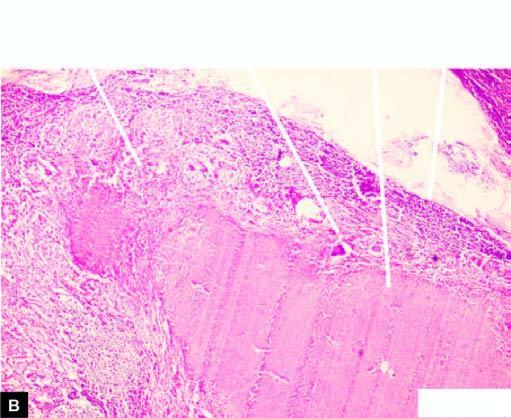does sectioned slice of the liver cut section of matted mass of lymph nodes show merging capsules and large areas of caseation necrosis?
Answer the question using a single word or phrase. No 